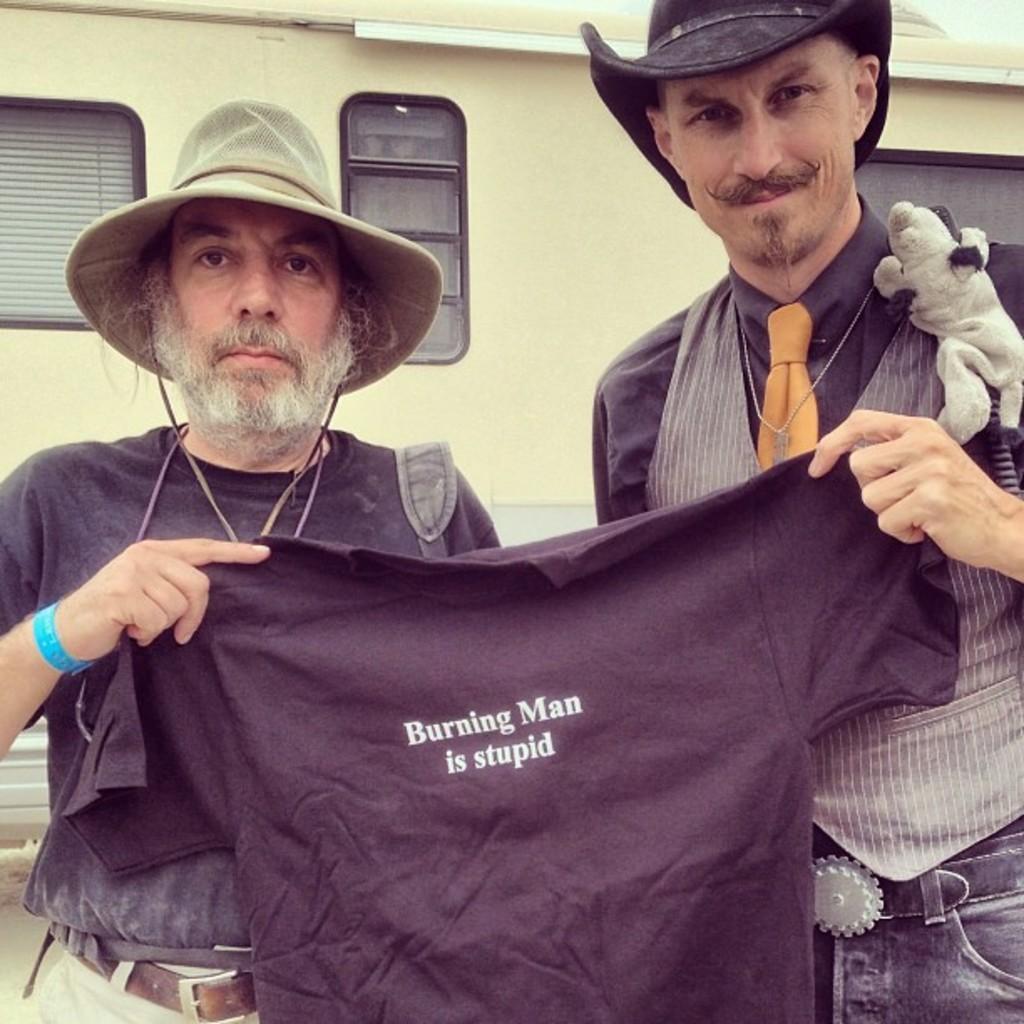In one or two sentences, can you explain what this image depicts? In this picture we can see two men standing and holding a t-shirt, they wore caps, in the background we can see a window here. 